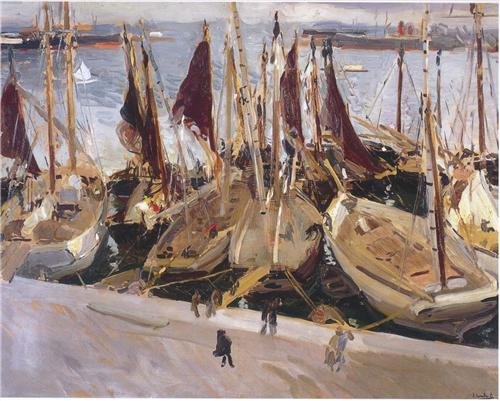Can you describe the harbor scene as if it were portrayed in an abstract painting? In an abstract rendition, the harbor scene would be reduced to a blend of shapes, colors, and textures. The sailboats might be represented by a series of overlapping triangles in varying sizes and shades of beige, white, and red. The water would be a mosaic of swirling blue and green patches, interspersed with reflective silver strokes to indicate light. The figures on the docks could be depicted as elongated, amorphous forms moving through the space. The distant city skyline would be a melange of soft, vertical lines and muted tones, receding into the background. The overall composition would focus more on the interplay of colors and shapes, conveying the energy and movement of the harbor without distinct, recognizable forms. 